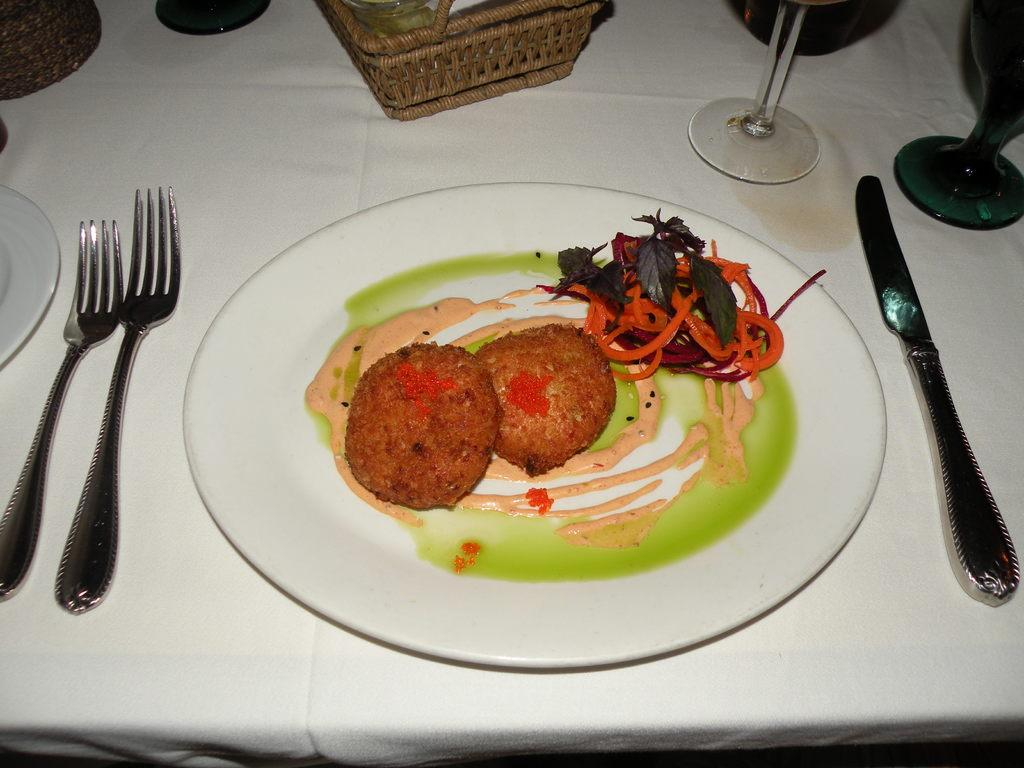What is on the plate in the image? There is food in the plate in the image. What utensils are present in the image? There are forks and a knife in the image. What type of container is visible in the image? There is a basket in the image. What can be used for drinking in the image? There are glasses on the table in the image. What type of cloud is present in the image? There are no clouds present in the image; it is focused on food and utensils on a table. 